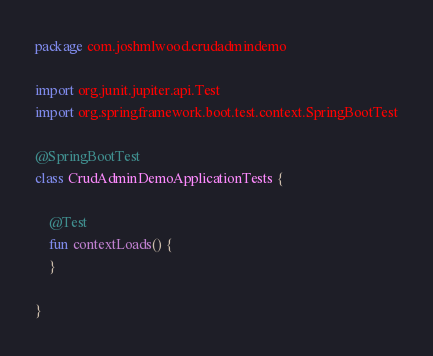Convert code to text. <code><loc_0><loc_0><loc_500><loc_500><_Kotlin_>package com.joshmlwood.crudadmindemo

import org.junit.jupiter.api.Test
import org.springframework.boot.test.context.SpringBootTest

@SpringBootTest
class CrudAdminDemoApplicationTests {

	@Test
	fun contextLoads() {
	}

}
</code> 